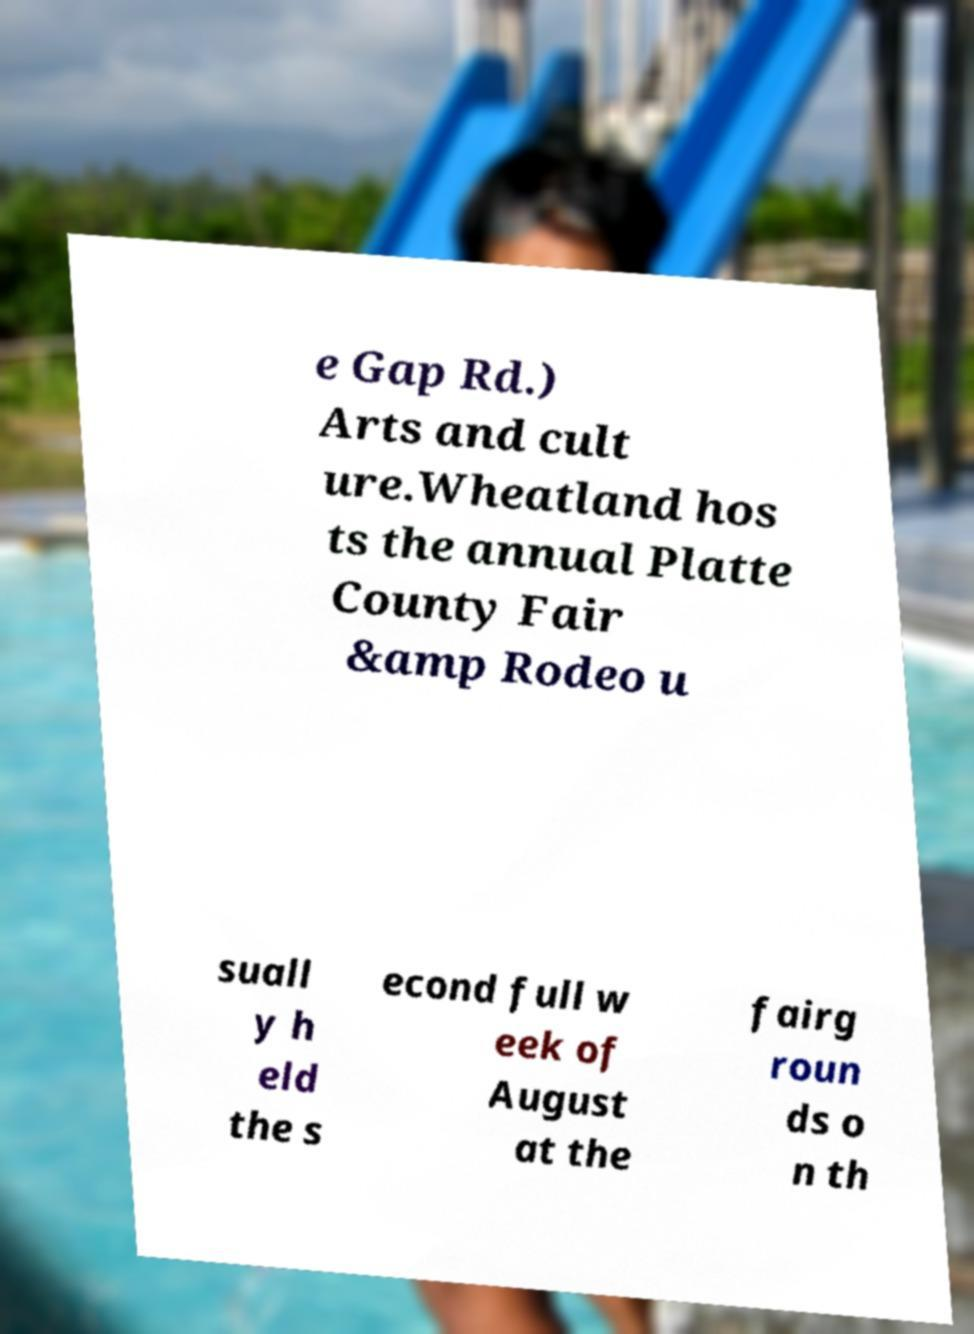Can you accurately transcribe the text from the provided image for me? e Gap Rd.) Arts and cult ure.Wheatland hos ts the annual Platte County Fair &amp Rodeo u suall y h eld the s econd full w eek of August at the fairg roun ds o n th 